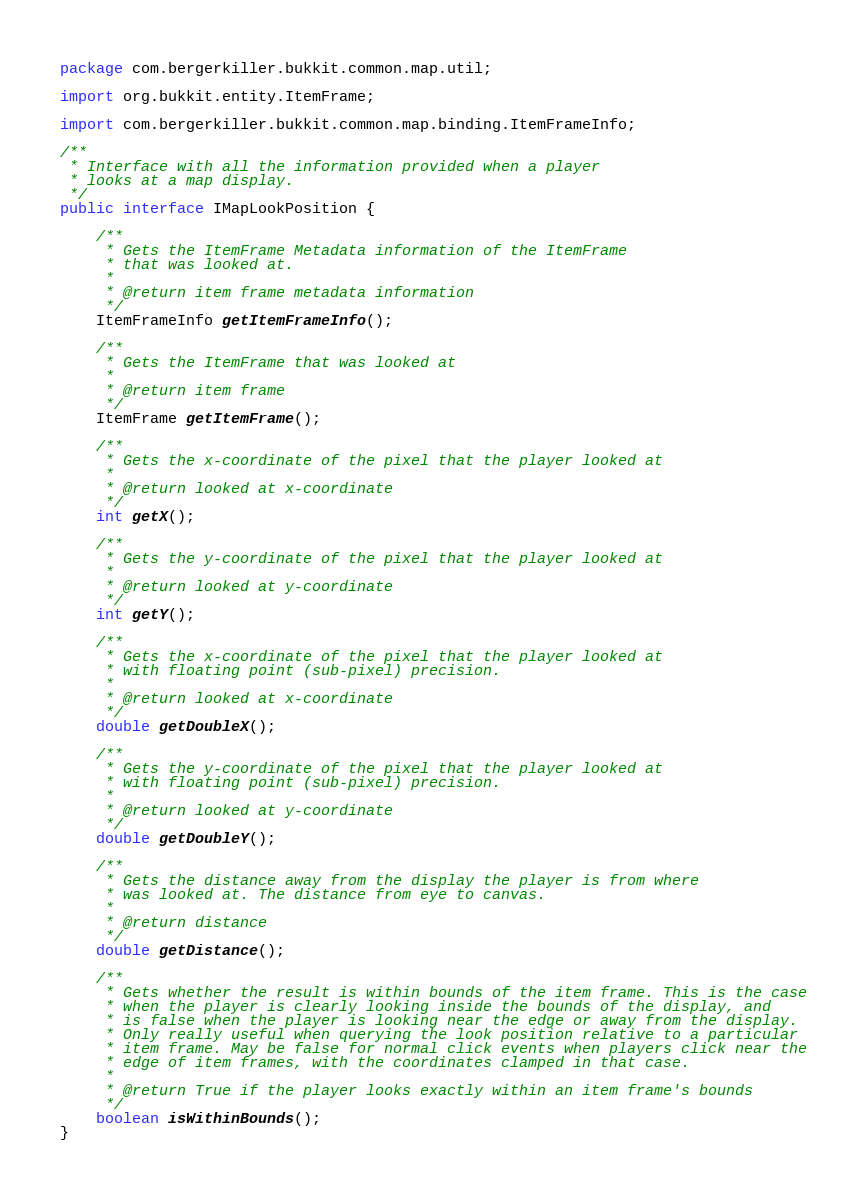Convert code to text. <code><loc_0><loc_0><loc_500><loc_500><_Java_>package com.bergerkiller.bukkit.common.map.util;

import org.bukkit.entity.ItemFrame;

import com.bergerkiller.bukkit.common.map.binding.ItemFrameInfo;

/**
 * Interface with all the information provided when a player
 * looks at a map display.
 */
public interface IMapLookPosition {

    /**
     * Gets the ItemFrame Metadata information of the ItemFrame
     * that was looked at.
     *
     * @return item frame metadata information
     */
    ItemFrameInfo getItemFrameInfo();

    /**
     * Gets the ItemFrame that was looked at
     * 
     * @return item frame
     */
    ItemFrame getItemFrame();

    /**
     * Gets the x-coordinate of the pixel that the player looked at
     * 
     * @return looked at x-coordinate
     */
    int getX();

    /**
     * Gets the y-coordinate of the pixel that the player looked at
     * 
     * @return looked at y-coordinate
     */
    int getY();

    /**
     * Gets the x-coordinate of the pixel that the player looked at
     * with floating point (sub-pixel) precision.
     * 
     * @return looked at x-coordinate
     */
    double getDoubleX();

    /**
     * Gets the y-coordinate of the pixel that the player looked at
     * with floating point (sub-pixel) precision.
     * 
     * @return looked at y-coordinate
     */
    double getDoubleY();

    /**
     * Gets the distance away from the display the player is from where
     * was looked at. The distance from eye to canvas.
     *
     * @return distance
     */
    double getDistance();

    /**
     * Gets whether the result is within bounds of the item frame. This is the case
     * when the player is clearly looking inside the bounds of the display, and
     * is false when the player is looking near the edge or away from the display.
     * Only really useful when querying the look position relative to a particular
     * item frame. May be false for normal click events when players click near the
     * edge of item frames, with the coordinates clamped in that case.
     *
     * @return True if the player looks exactly within an item frame's bounds
     */
    boolean isWithinBounds();
}
</code> 